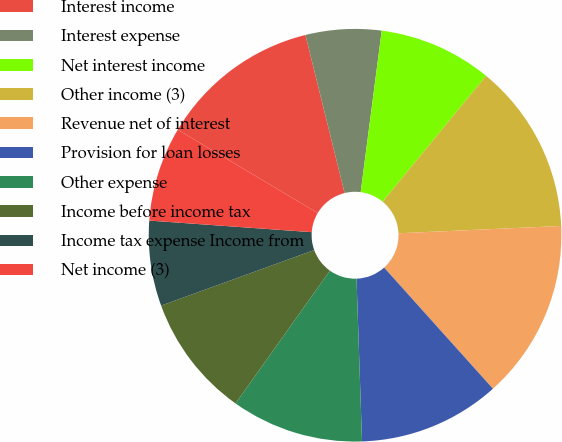Convert chart. <chart><loc_0><loc_0><loc_500><loc_500><pie_chart><fcel>Interest income<fcel>Interest expense<fcel>Net interest income<fcel>Other income (3)<fcel>Revenue net of interest<fcel>Provision for loan losses<fcel>Other expense<fcel>Income before income tax<fcel>Income tax expense Income from<fcel>Net income (3)<nl><fcel>12.59%<fcel>5.93%<fcel>8.89%<fcel>13.33%<fcel>14.07%<fcel>11.11%<fcel>10.37%<fcel>9.63%<fcel>6.67%<fcel>7.41%<nl></chart> 